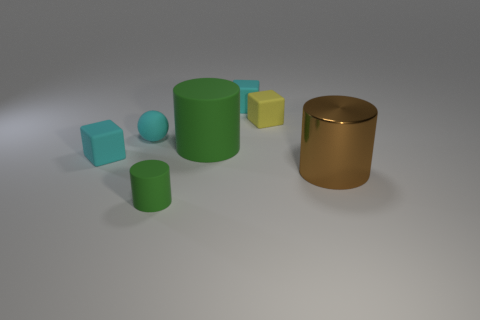Subtract all tiny cyan blocks. How many blocks are left? 1 Add 3 large brown shiny cylinders. How many objects exist? 10 Subtract all cyan blocks. How many blocks are left? 1 Subtract all large shiny cylinders. Subtract all brown cylinders. How many objects are left? 5 Add 4 large metal things. How many large metal things are left? 5 Add 5 small yellow shiny spheres. How many small yellow shiny spheres exist? 5 Subtract 0 gray cylinders. How many objects are left? 7 Subtract all spheres. How many objects are left? 6 Subtract all red spheres. Subtract all purple cylinders. How many spheres are left? 1 Subtract all red cylinders. How many yellow cubes are left? 1 